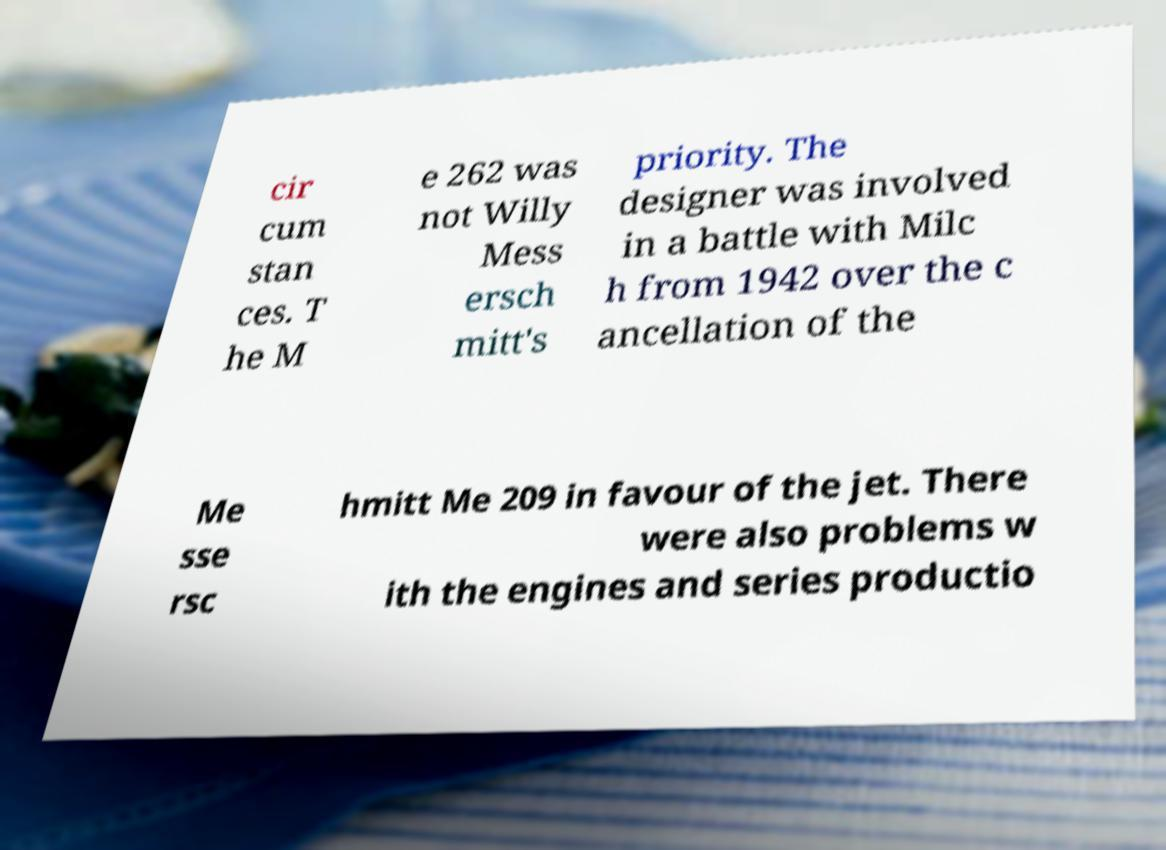Could you extract and type out the text from this image? cir cum stan ces. T he M e 262 was not Willy Mess ersch mitt's priority. The designer was involved in a battle with Milc h from 1942 over the c ancellation of the Me sse rsc hmitt Me 209 in favour of the jet. There were also problems w ith the engines and series productio 